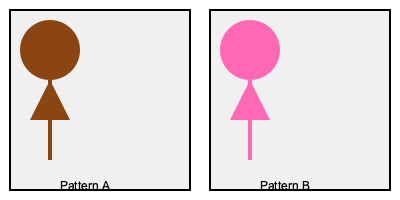Which pattern represents cultural appropriation of an indigenous design, and why? To identify cultural appropriation in fashion designs, we need to analyze both patterns:

1. Pattern A:
   - Uses earth tones (brown)
   - Simple, geometric shapes
   - Resembles traditional indigenous symbols (e.g., circle for sun, triangle for mountain)

2. Pattern B:
   - Uses bright, non-traditional colors (pink)
   - Mimics the structure of Pattern A
   - Lacks cultural context and meaning

3. Cultural appropriation indicators:
   - Borrowing elements without understanding or respecting their cultural significance
   - Using traditional designs out of context
   - Altering colors or elements to fit mainstream fashion trends

4. Analysis:
   - Pattern A appears to be an authentic indigenous design
   - Pattern B copies the structure but changes colors and lacks cultural understanding

5. Conclusion:
   Pattern B represents cultural appropriation because it takes elements from an indigenous design (Pattern A) and alters them without respect for their cultural significance, using non-traditional colors and removing the context.
Answer: Pattern B 